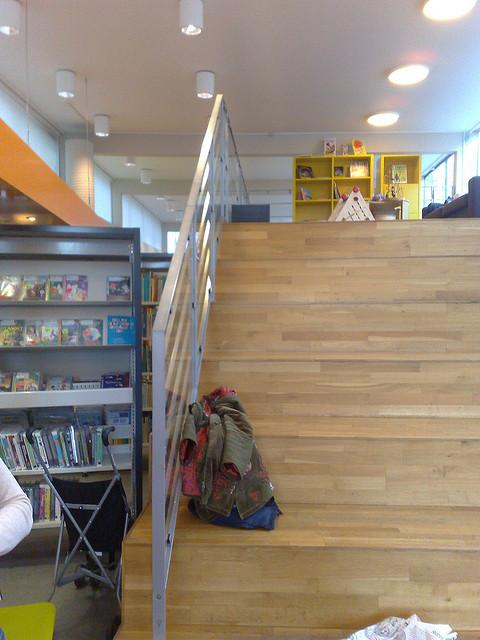What is next to the wooden steps?

Choices:
A) railing
B) dog
C) cat
D) egg railing 